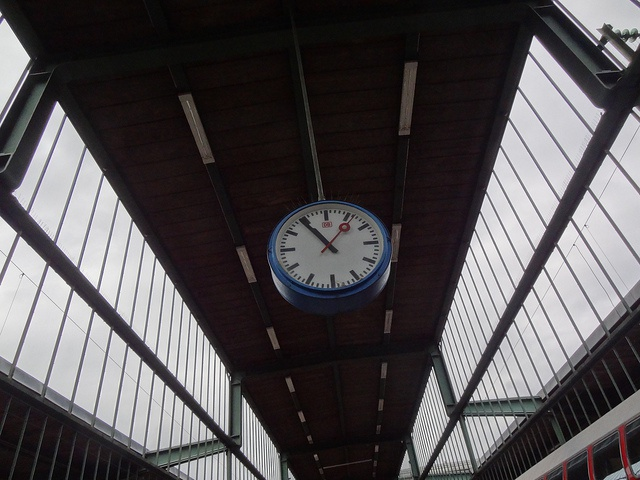Describe the objects in this image and their specific colors. I can see a clock in black and gray tones in this image. 